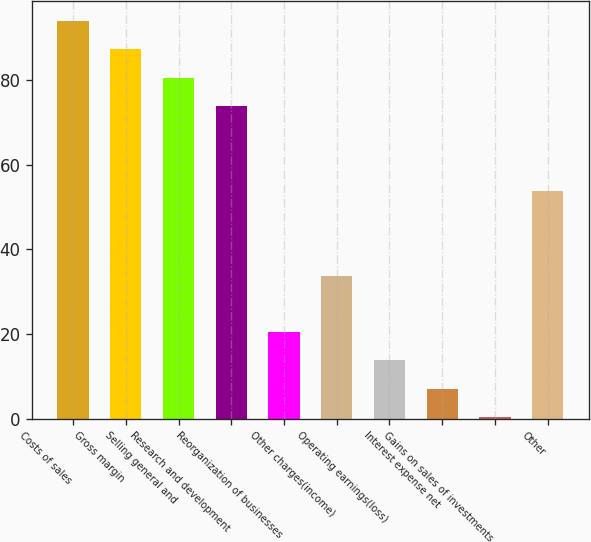Convert chart. <chart><loc_0><loc_0><loc_500><loc_500><bar_chart><fcel>Costs of sales<fcel>Gross margin<fcel>Selling general and<fcel>Research and development<fcel>Reorganization of businesses<fcel>Other charges(income)<fcel>Operating earnings(loss)<fcel>Interest expense net<fcel>Gains on sales of investments<fcel>Other<nl><fcel>93.92<fcel>87.24<fcel>80.56<fcel>73.88<fcel>20.44<fcel>33.8<fcel>13.76<fcel>7.08<fcel>0.4<fcel>53.84<nl></chart> 